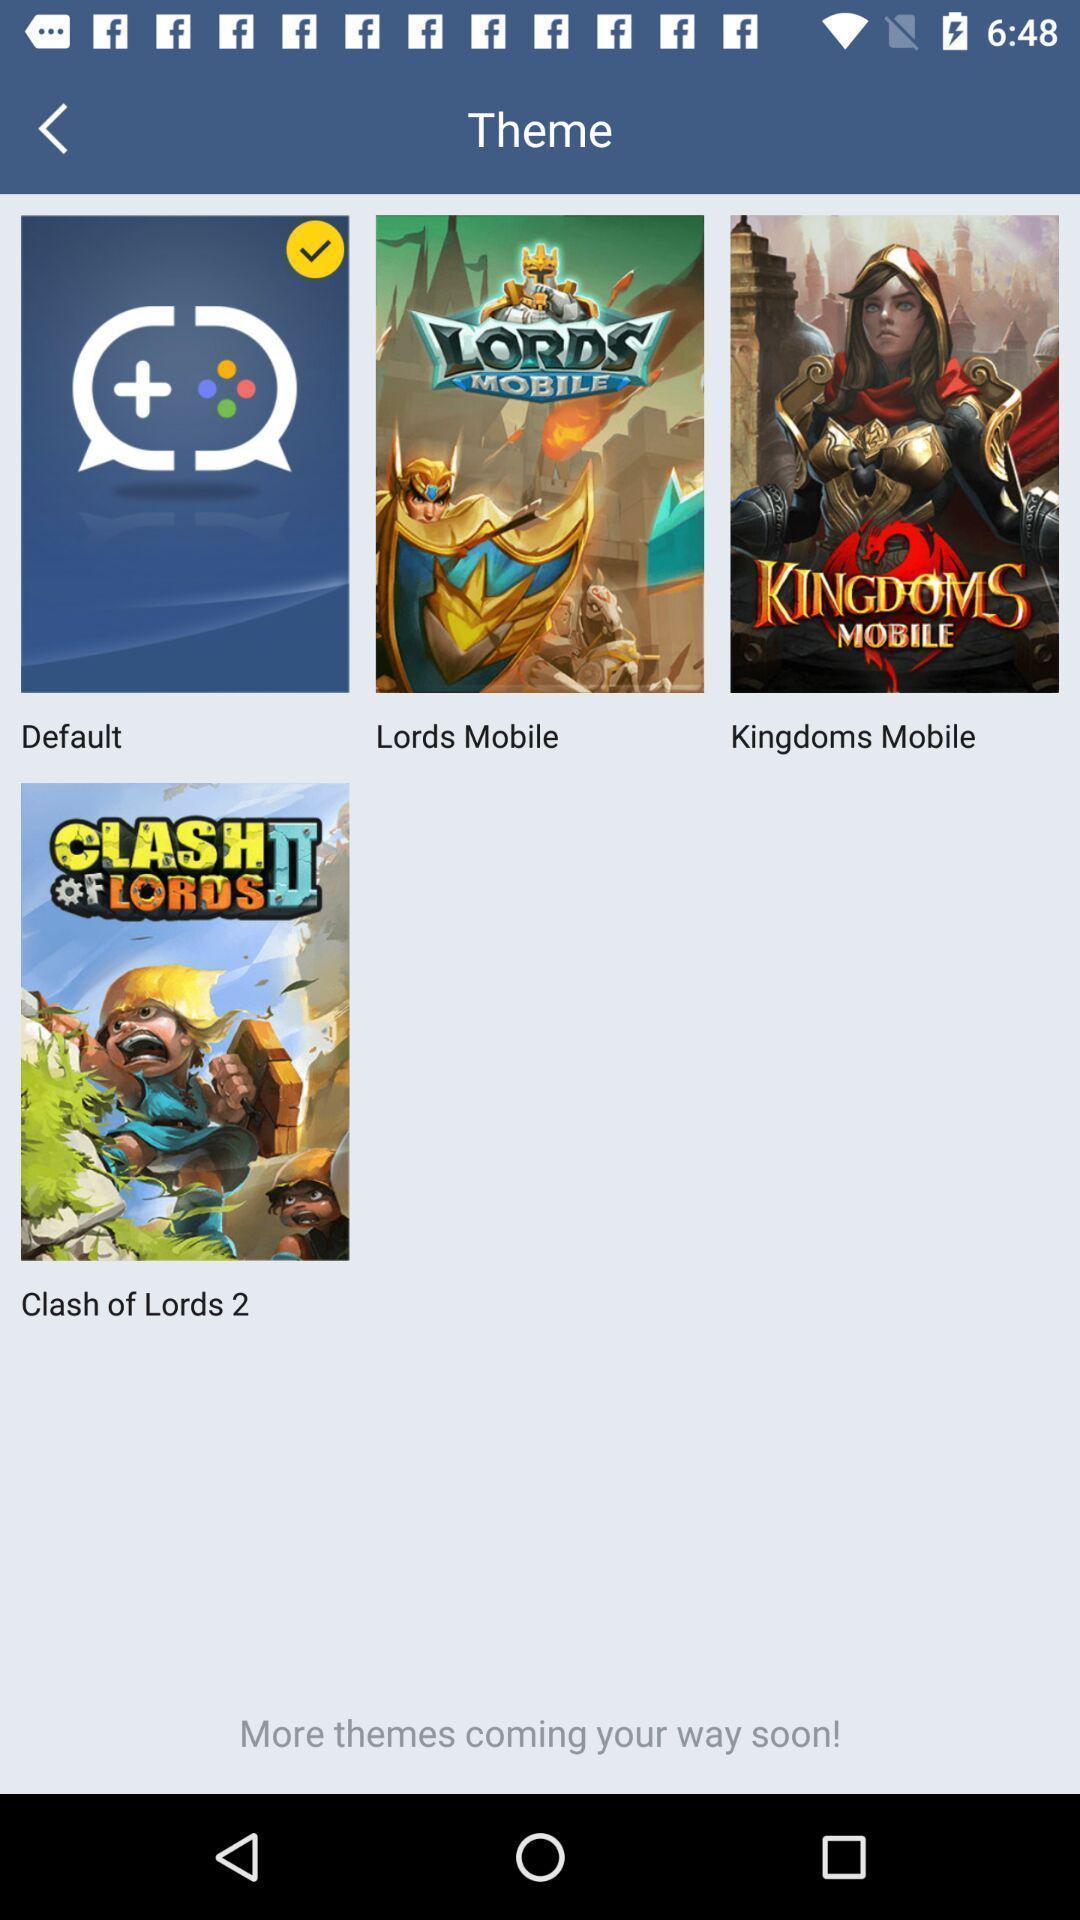Describe the key features of this screenshot. Various themes displayed. 